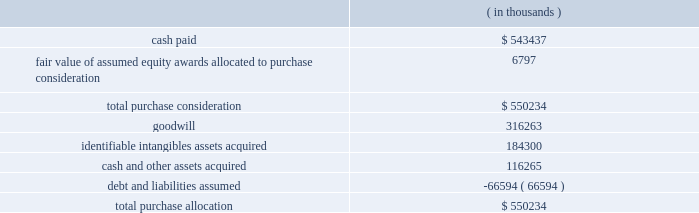Synopsys , inc .
Notes to consolidated financial statements 2014continued acquisition of magma design automation , inc .
( magma ) on february 22 , 2012 , the company acquired all outstanding shares of magma , a chip design software provider , at a per-share price of $ 7.35 .
Additionally , the company assumed unvested restricted stock units ( rsus ) and stock options , collectively called 201cequity awards . 201d the aggregate purchase price was approximately $ 550.2 million .
This acquisition enables the company to more rapidly meet the needs of leading-edge semiconductor designers for more sophisticated design tools .
As of october 31 , 2012 , the total purchase consideration and the preliminary purchase price allocation were as follows: .
Goodwill of $ 316.3 million , which is not deductible for tax purposes , primarily resulted from the company 2019s expectation of sales growth and cost synergies from the integration of magma 2019s technology and operations with the company 2019s technology and operations .
Identifiable intangible assets , consisting primarily of technology , customer relationships , backlog and trademarks , were valued using the income method , and are being amortized over three to ten years .
Acquisition-related costs directly attributable to the business combination totaling $ 33.5 million for fiscal 2012 were expensed as incurred in the consolidated statements of operations and consist primarily of employee separation costs , contract terminations , professional services , and facilities closure costs .
Fair value of equity awards assumed .
The company assumed unvested restricted stock units ( rsus ) and stock options with a fair value of $ 22.2 million .
The black-scholes option-pricing model was used to determine the fair value of these stock options , whereas the fair value of the rsus was based on the market price on the grant date of the instruments .
The black-scholes option-pricing model incorporates various subjective assumptions including expected volatility , expected term and risk-free interest rates .
The expected volatility was estimated by a combination of implied and historical stock price volatility of the options .
Of the total fair value of the equity awards assumed , $ 6.8 million was allocated to the purchase consideration and $ 15.4 million was allocated to future services to be expensed over their remaining service periods on a straight-line basis .
Supplemental pro forma information ( unaudited ) .
The financial information in the table below summarizes the combined results of operations of the company and magma , on a pro forma basis , as though the companies had been combined as of the beginning of fiscal 2011. .
What percentage of total purchase allocation was goodwill? 
Computations: (316263 / 550234)
Answer: 0.57478. 